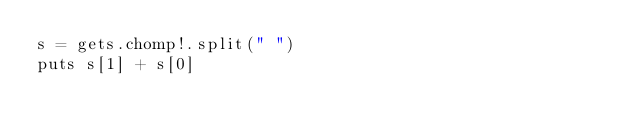Convert code to text. <code><loc_0><loc_0><loc_500><loc_500><_Ruby_>s = gets.chomp!.split(" ")
puts s[1] + s[0]</code> 